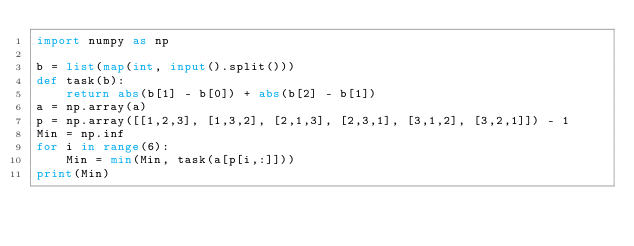<code> <loc_0><loc_0><loc_500><loc_500><_Python_>import numpy as np

b = list(map(int, input().split()))
def task(b):
    return abs(b[1] - b[0]) + abs(b[2] - b[1])
a = np.array(a)
p = np.array([[1,2,3], [1,3,2], [2,1,3], [2,3,1], [3,1,2], [3,2,1]]) - 1
Min = np.inf
for i in range(6):
    Min = min(Min, task(a[p[i,:]]))
print(Min)
</code> 